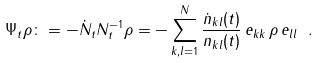<formula> <loc_0><loc_0><loc_500><loc_500>\Psi _ { t } \rho \colon = - \dot { N } _ { t } N _ { t } ^ { - 1 } \rho = - \sum _ { k , l = 1 } ^ { N } \frac { \dot { n } _ { k l } ( t ) } { n _ { k l } ( t ) } \, e _ { k k } \, \rho \, e _ { l l } \ .</formula> 